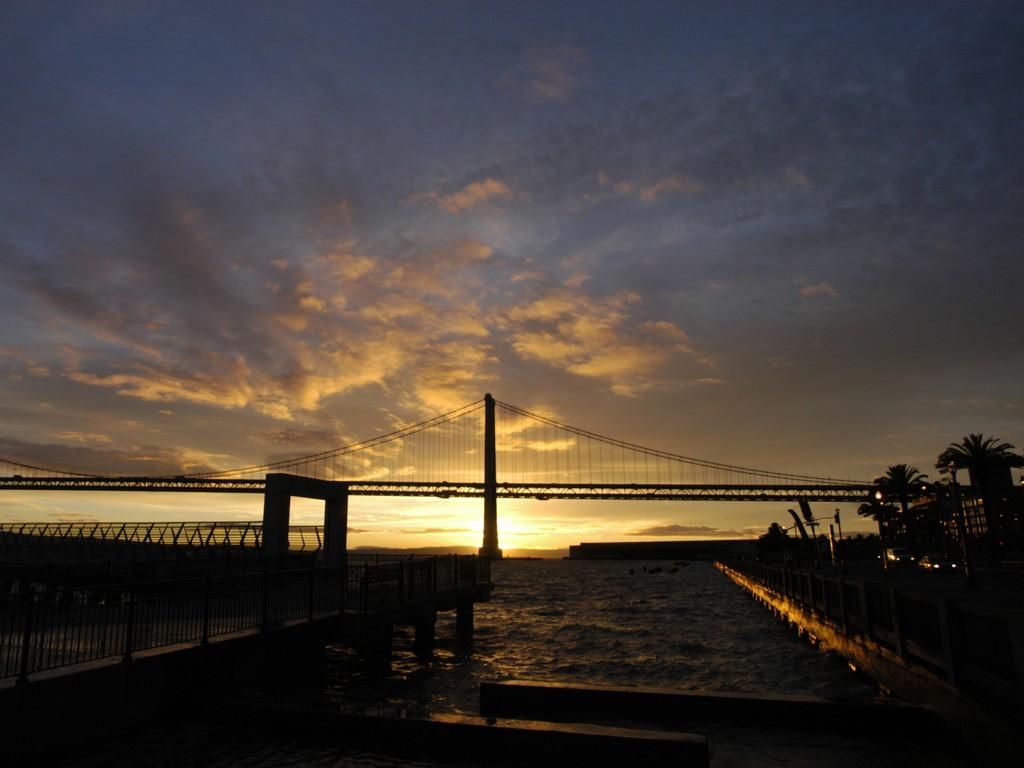What is the overall lighting condition of the image? The image is dark. What structure can be seen in the image? There is a bridge in the image. What natural element is present in the image? There is water in the image. What type of vegetation is on the right side of the image? There are trees on the right side of the image. What is visible at the top of the image? The sky is visible at the top of the image. Can you tell me how many fairies are flying around the bridge in the image? There are no fairies present in the image; it features a bridge, water, trees, and a dark sky. What type of watch is visible on the right side of the image? There is no watch present in the image. 